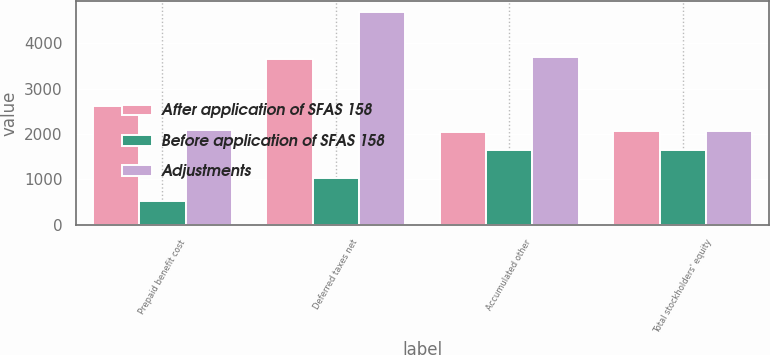Convert chart. <chart><loc_0><loc_0><loc_500><loc_500><stacked_bar_chart><ecel><fcel>Prepaid benefit cost<fcel>Deferred taxes net<fcel>Accumulated other<fcel>Total stockholders' equity<nl><fcel>After application of SFAS 158<fcel>2620<fcel>3653<fcel>2053<fcel>2069.5<nl><fcel>Before application of SFAS 158<fcel>534<fcel>1034<fcel>1647<fcel>1647<nl><fcel>Adjustments<fcel>2086<fcel>4687<fcel>3700<fcel>2069.5<nl></chart> 